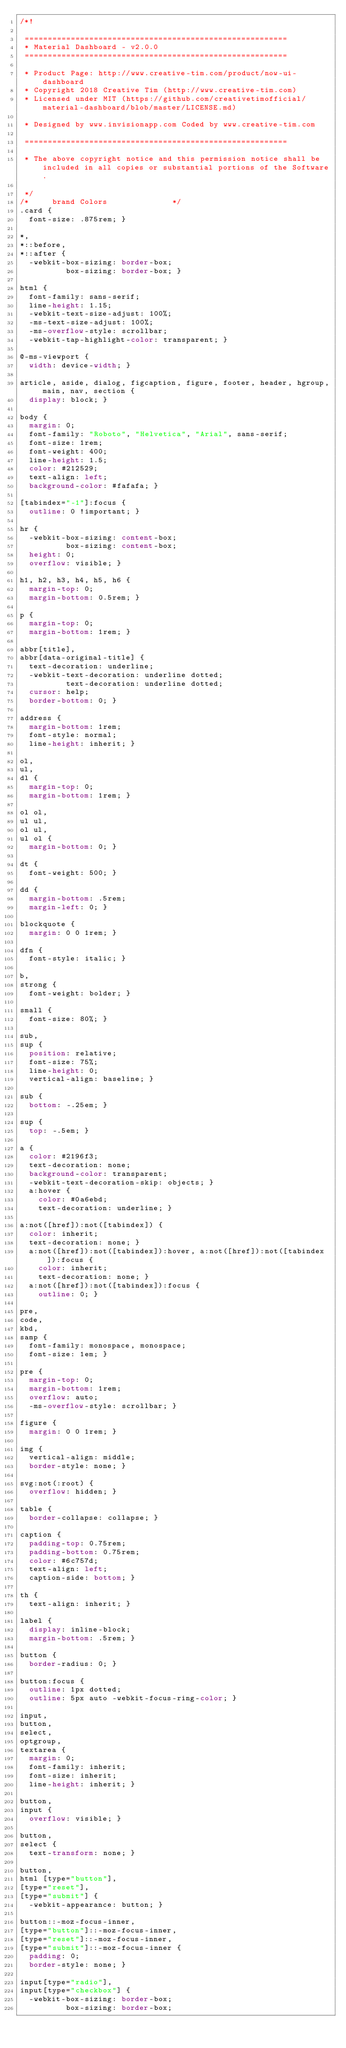<code> <loc_0><loc_0><loc_500><loc_500><_CSS_>/*!

 =========================================================
 * Material Dashboard - v2.0.0
 =========================================================

 * Product Page: http://www.creative-tim.com/product/now-ui-dashboard
 * Copyright 2018 Creative Tim (http://www.creative-tim.com)
 * Licensed under MIT (https://github.com/creativetimofficial/material-dashboard/blob/master/LICENSE.md)

 * Designed by www.invisionapp.com Coded by www.creative-tim.com

 =========================================================

 * The above copyright notice and this permission notice shall be included in all copies or substantial portions of the Software.

 */
/*     brand Colors              */
.card {
  font-size: .875rem; }

*,
*::before,
*::after {
  -webkit-box-sizing: border-box;
          box-sizing: border-box; }

html {
  font-family: sans-serif;
  line-height: 1.15;
  -webkit-text-size-adjust: 100%;
  -ms-text-size-adjust: 100%;
  -ms-overflow-style: scrollbar;
  -webkit-tap-highlight-color: transparent; }

@-ms-viewport {
  width: device-width; }

article, aside, dialog, figcaption, figure, footer, header, hgroup, main, nav, section {
  display: block; }

body {
  margin: 0;
  font-family: "Roboto", "Helvetica", "Arial", sans-serif;
  font-size: 1rem;
  font-weight: 400;
  line-height: 1.5;
  color: #212529;
  text-align: left;
  background-color: #fafafa; }

[tabindex="-1"]:focus {
  outline: 0 !important; }

hr {
  -webkit-box-sizing: content-box;
          box-sizing: content-box;
  height: 0;
  overflow: visible; }

h1, h2, h3, h4, h5, h6 {
  margin-top: 0;
  margin-bottom: 0.5rem; }

p {
  margin-top: 0;
  margin-bottom: 1rem; }

abbr[title],
abbr[data-original-title] {
  text-decoration: underline;
  -webkit-text-decoration: underline dotted;
          text-decoration: underline dotted;
  cursor: help;
  border-bottom: 0; }

address {
  margin-bottom: 1rem;
  font-style: normal;
  line-height: inherit; }

ol,
ul,
dl {
  margin-top: 0;
  margin-bottom: 1rem; }

ol ol,
ul ul,
ol ul,
ul ol {
  margin-bottom: 0; }

dt {
  font-weight: 500; }

dd {
  margin-bottom: .5rem;
  margin-left: 0; }

blockquote {
  margin: 0 0 1rem; }

dfn {
  font-style: italic; }

b,
strong {
  font-weight: bolder; }

small {
  font-size: 80%; }

sub,
sup {
  position: relative;
  font-size: 75%;
  line-height: 0;
  vertical-align: baseline; }

sub {
  bottom: -.25em; }

sup {
  top: -.5em; }

a {
  color: #2196f3;
  text-decoration: none;
  background-color: transparent;
  -webkit-text-decoration-skip: objects; }
  a:hover {
    color: #0a6ebd;
    text-decoration: underline; }

a:not([href]):not([tabindex]) {
  color: inherit;
  text-decoration: none; }
  a:not([href]):not([tabindex]):hover, a:not([href]):not([tabindex]):focus {
    color: inherit;
    text-decoration: none; }
  a:not([href]):not([tabindex]):focus {
    outline: 0; }

pre,
code,
kbd,
samp {
  font-family: monospace, monospace;
  font-size: 1em; }

pre {
  margin-top: 0;
  margin-bottom: 1rem;
  overflow: auto;
  -ms-overflow-style: scrollbar; }

figure {
  margin: 0 0 1rem; }

img {
  vertical-align: middle;
  border-style: none; }

svg:not(:root) {
  overflow: hidden; }

table {
  border-collapse: collapse; }

caption {
  padding-top: 0.75rem;
  padding-bottom: 0.75rem;
  color: #6c757d;
  text-align: left;
  caption-side: bottom; }

th {
  text-align: inherit; }

label {
  display: inline-block;
  margin-bottom: .5rem; }

button {
  border-radius: 0; }

button:focus {
  outline: 1px dotted;
  outline: 5px auto -webkit-focus-ring-color; }

input,
button,
select,
optgroup,
textarea {
  margin: 0;
  font-family: inherit;
  font-size: inherit;
  line-height: inherit; }

button,
input {
  overflow: visible; }

button,
select {
  text-transform: none; }

button,
html [type="button"],
[type="reset"],
[type="submit"] {
  -webkit-appearance: button; }

button::-moz-focus-inner,
[type="button"]::-moz-focus-inner,
[type="reset"]::-moz-focus-inner,
[type="submit"]::-moz-focus-inner {
  padding: 0;
  border-style: none; }

input[type="radio"],
input[type="checkbox"] {
  -webkit-box-sizing: border-box;
          box-sizing: border-box;</code> 